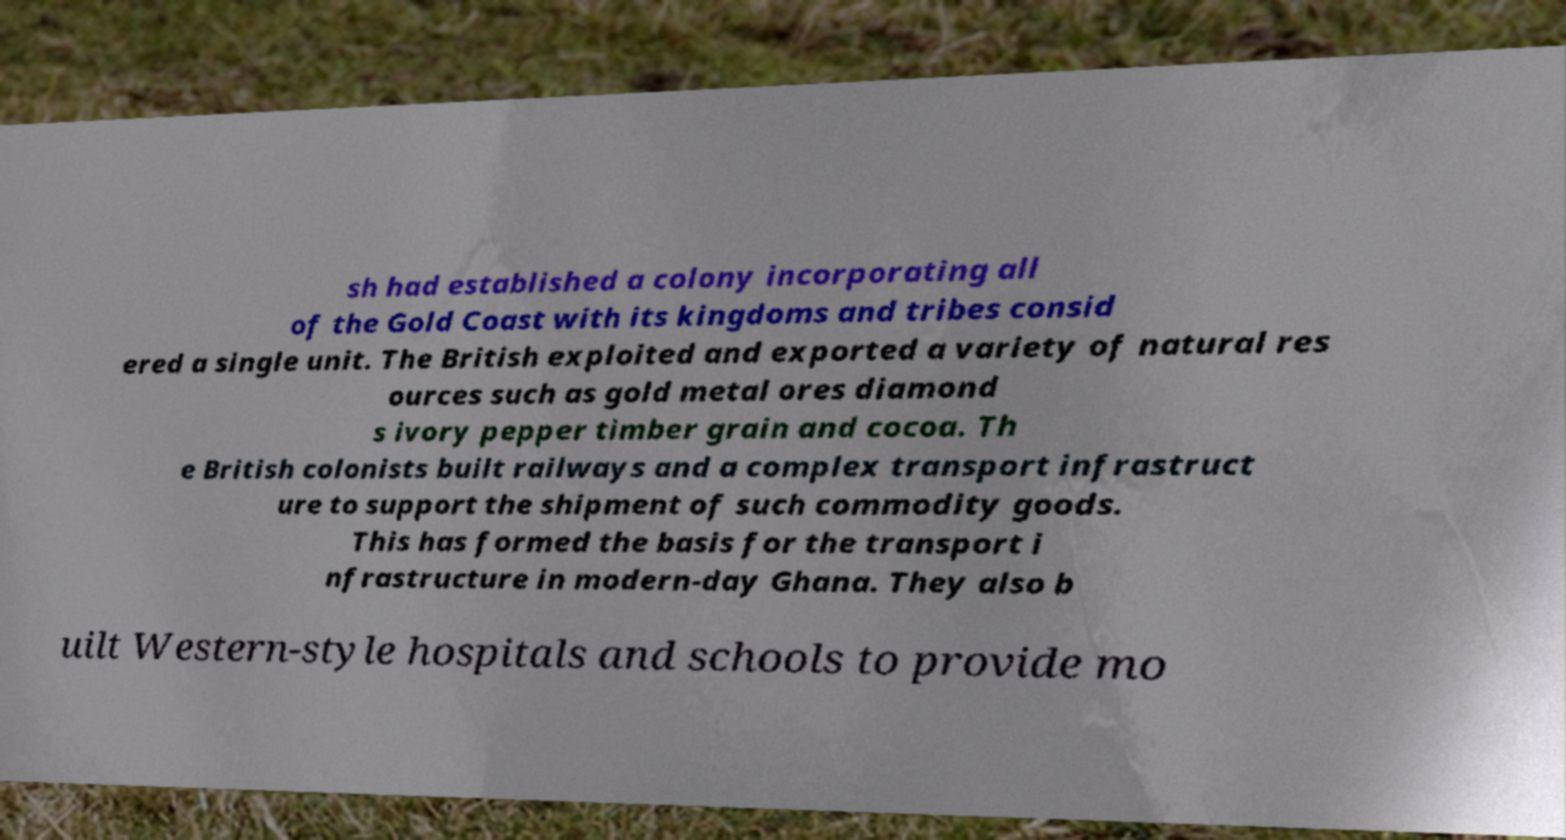Can you read and provide the text displayed in the image?This photo seems to have some interesting text. Can you extract and type it out for me? sh had established a colony incorporating all of the Gold Coast with its kingdoms and tribes consid ered a single unit. The British exploited and exported a variety of natural res ources such as gold metal ores diamond s ivory pepper timber grain and cocoa. Th e British colonists built railways and a complex transport infrastruct ure to support the shipment of such commodity goods. This has formed the basis for the transport i nfrastructure in modern-day Ghana. They also b uilt Western-style hospitals and schools to provide mo 